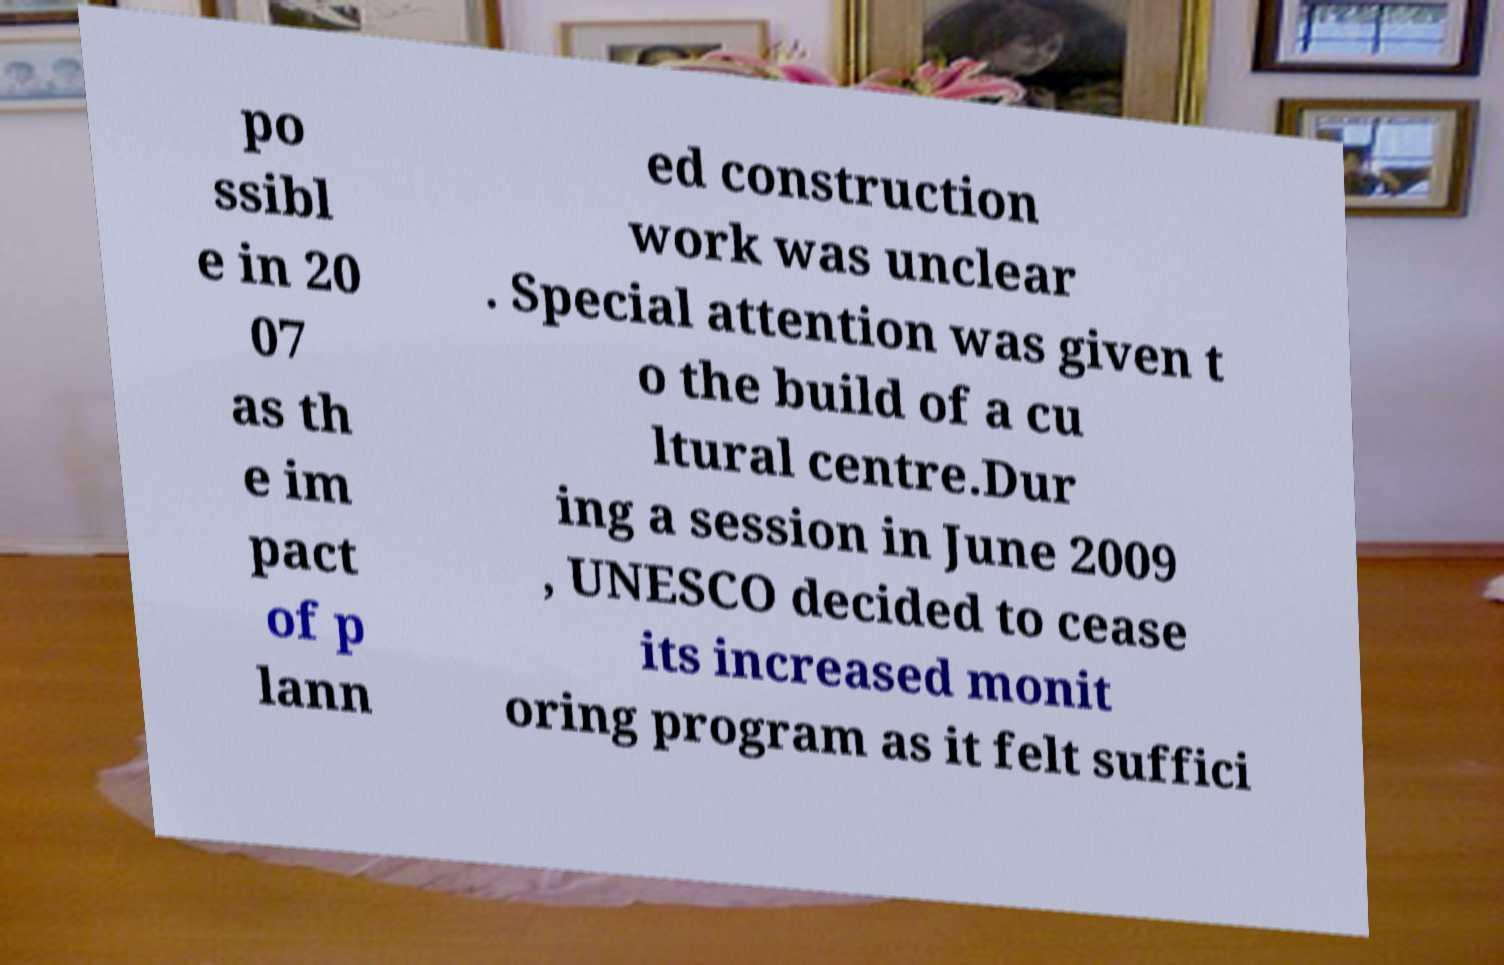Could you assist in decoding the text presented in this image and type it out clearly? po ssibl e in 20 07 as th e im pact of p lann ed construction work was unclear . Special attention was given t o the build of a cu ltural centre.Dur ing a session in June 2009 , UNESCO decided to cease its increased monit oring program as it felt suffici 